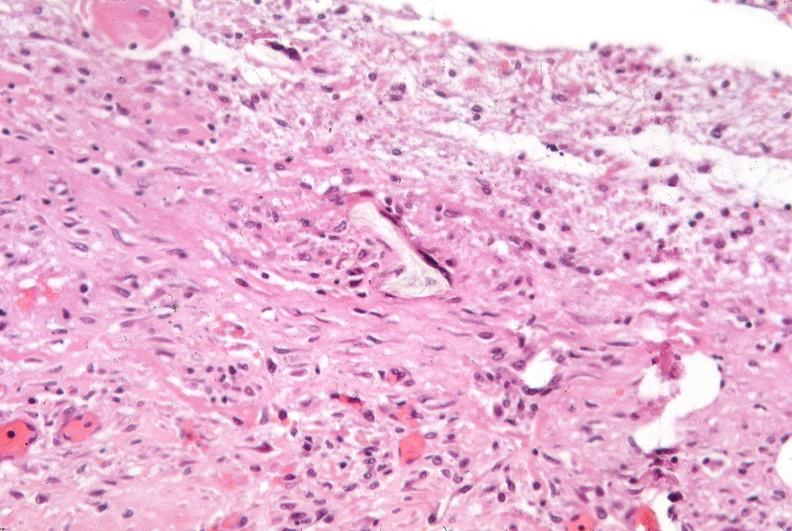was chronic myelogenous leukemia used to sclerose emphysematous lung, alpha-1 antitrypsin deficiency?
Answer the question using a single word or phrase. No 